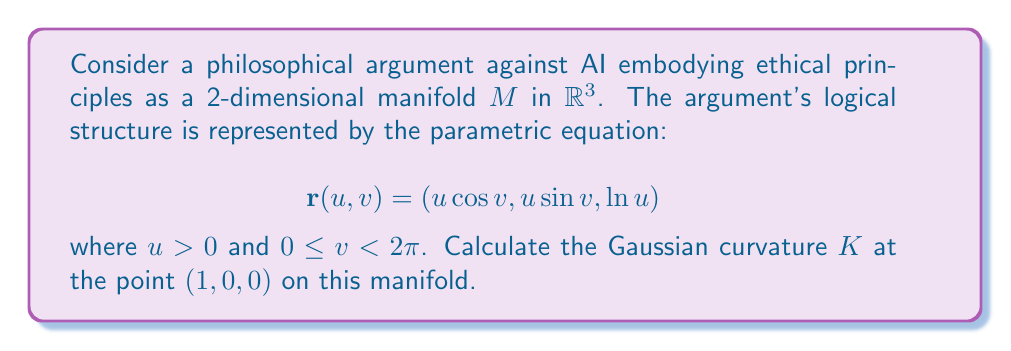Help me with this question. To calculate the Gaussian curvature, we'll follow these steps:

1) First, we need to compute the first fundamental form coefficients $E$, $F$, and $G$:

   $$\mathbf{r}_u = (\cos v, \sin v, \frac{1}{u})$$
   $$\mathbf{r}_v = (-u\sin v, u\cos v, 0)$$

   $$E = \mathbf{r}_u \cdot \mathbf{r}_u = \cos^2 v + \sin^2 v + \frac{1}{u^2} = 1 + \frac{1}{u^2}$$
   $$F = \mathbf{r}_u \cdot \mathbf{r}_v = 0$$
   $$G = \mathbf{r}_v \cdot \mathbf{r}_v = u^2\sin^2 v + u^2\cos^2 v = u^2$$

2) Next, we compute the second fundamental form coefficients $L$, $M$, and $N$:

   $$\mathbf{r}_{uu} = (0, 0, -\frac{1}{u^2})$$
   $$\mathbf{r}_{uv} = (-\sin v, \cos v, 0)$$
   $$\mathbf{r}_{vv} = (-u\cos v, -u\sin v, 0)$$

   $$\mathbf{n} = \frac{\mathbf{r}_u \times \mathbf{r}_v}{|\mathbf{r}_u \times \mathbf{r}_v|} = \frac{(-\frac{\cos v}{u}, -\frac{\sin v}{u}, 1)}{\sqrt{1 + \frac{1}{u^2}}}$$

   $$L = \mathbf{r}_{uu} \cdot \mathbf{n} = -\frac{1}{u^2\sqrt{1 + \frac{1}{u^2}}}$$
   $$M = \mathbf{r}_{uv} \cdot \mathbf{n} = 0$$
   $$N = \mathbf{r}_{vv} \cdot \mathbf{n} = -\frac{u}{\sqrt{1 + \frac{1}{u^2}}}$$

3) The Gaussian curvature is given by:

   $$K = \frac{LN - M^2}{EG - F^2}$$

4) Substituting the values at the point $(1, 0, 0)$, which corresponds to $u = 1$ and $v = 0$:

   $$E = 2, F = 0, G = 1$$
   $$L = -\frac{1}{\sqrt{2}}, M = 0, N = -\frac{1}{\sqrt{2}}$$

5) Calculate $K$:

   $$K = \frac{(-\frac{1}{\sqrt{2}})(-\frac{1}{\sqrt{2}}) - 0^2}{(2)(1) - 0^2} = \frac{1/2}{2} = \frac{1}{4}$$

Thus, the Gaussian curvature at the point $(1, 0, 0)$ is $\frac{1}{4}$.
Answer: $K = \frac{1}{4}$ 